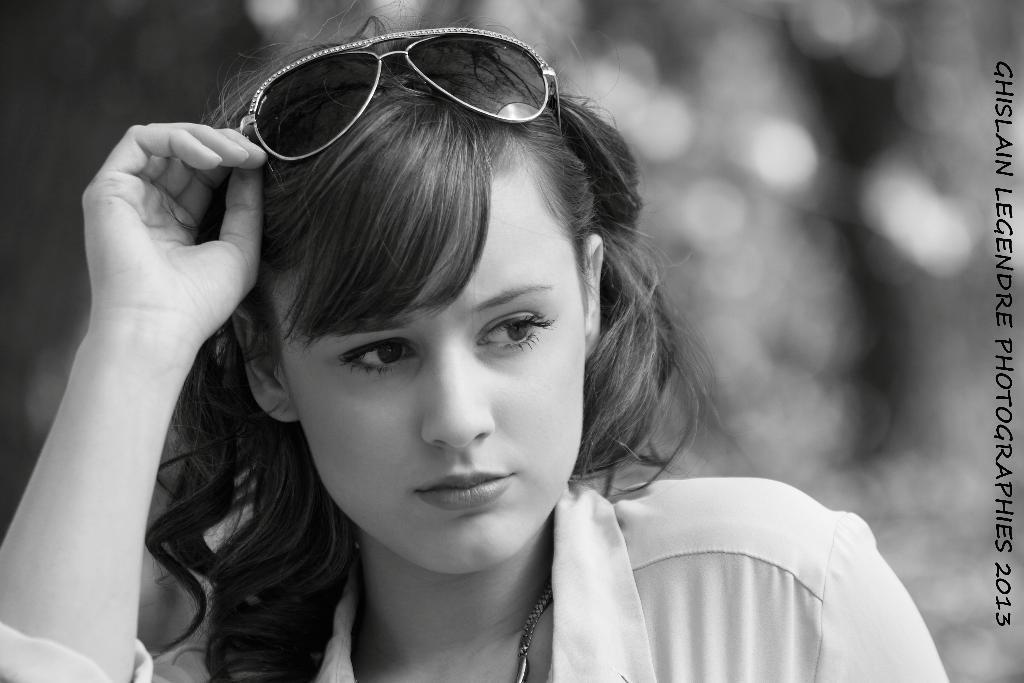What is the main subject of the image? There is a person in the image. Can you describe the person's appearance? The person is wearing spectacles. What can be observed about the background of the image? The background of the image is blurred. Is there any additional information or markings on the image? There is a watermark on the image. What type of hydrant is visible in the image? There is no hydrant present in the image. How does the person manage their waste in the image? There is no information about waste management in the image. 